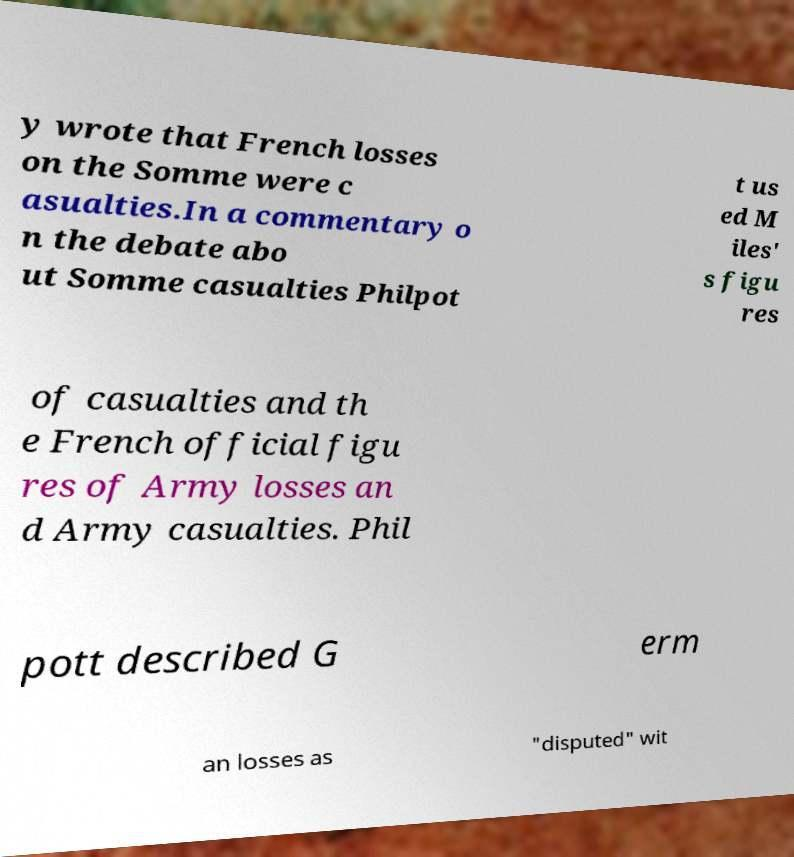Can you accurately transcribe the text from the provided image for me? y wrote that French losses on the Somme were c asualties.In a commentary o n the debate abo ut Somme casualties Philpot t us ed M iles' s figu res of casualties and th e French official figu res of Army losses an d Army casualties. Phil pott described G erm an losses as "disputed" wit 